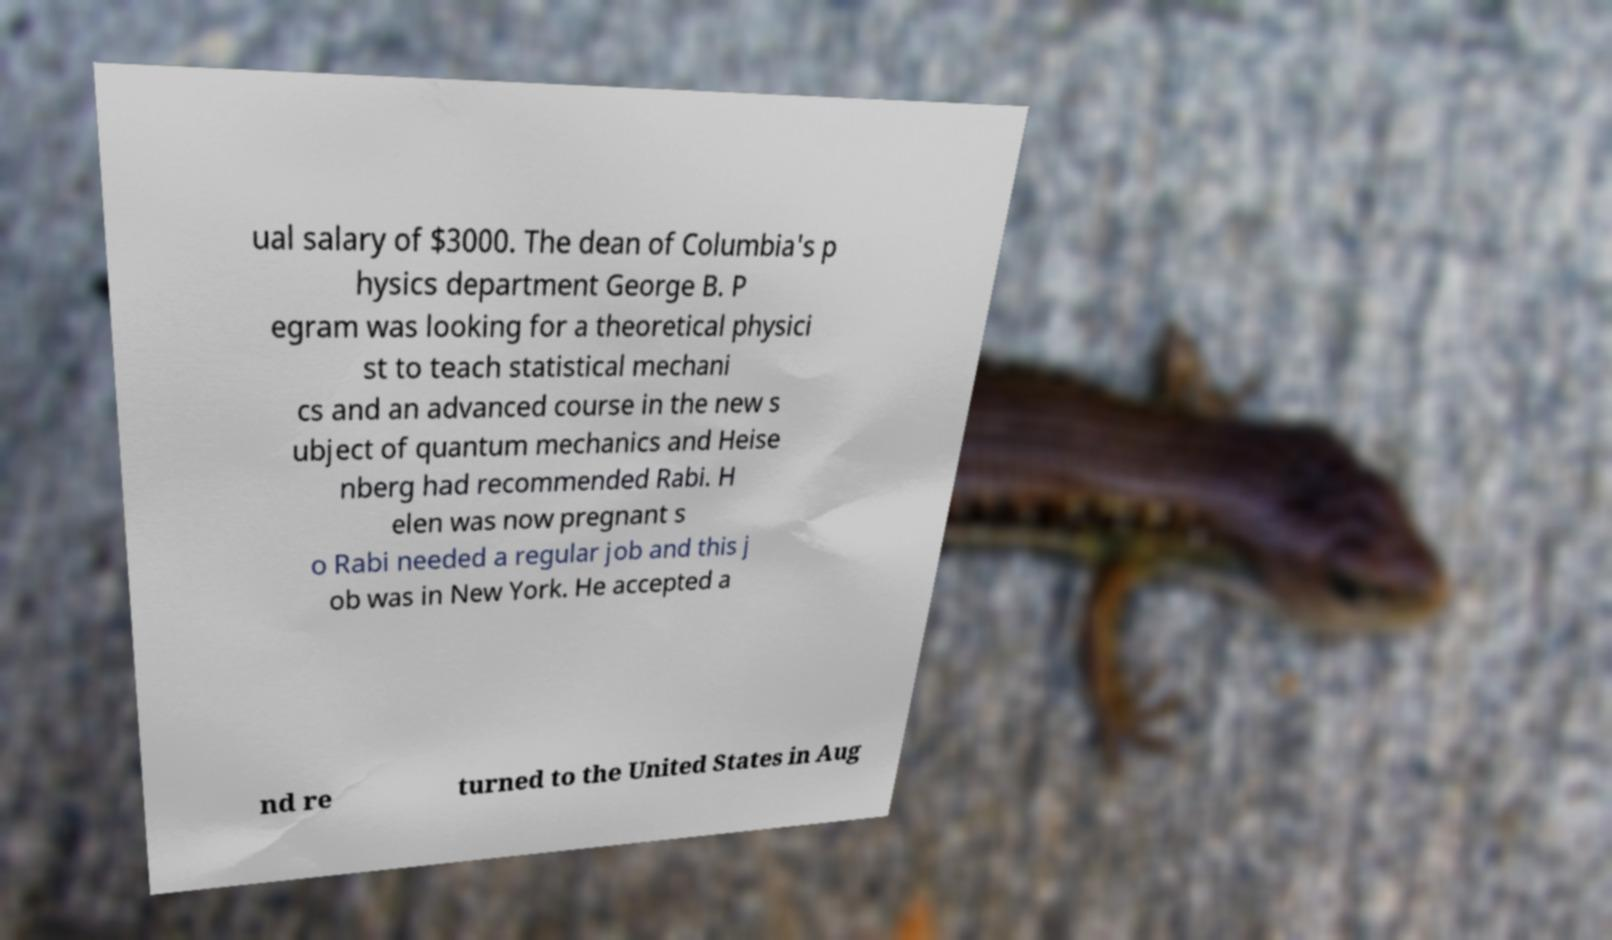Can you read and provide the text displayed in the image?This photo seems to have some interesting text. Can you extract and type it out for me? ual salary of $3000. The dean of Columbia's p hysics department George B. P egram was looking for a theoretical physici st to teach statistical mechani cs and an advanced course in the new s ubject of quantum mechanics and Heise nberg had recommended Rabi. H elen was now pregnant s o Rabi needed a regular job and this j ob was in New York. He accepted a nd re turned to the United States in Aug 